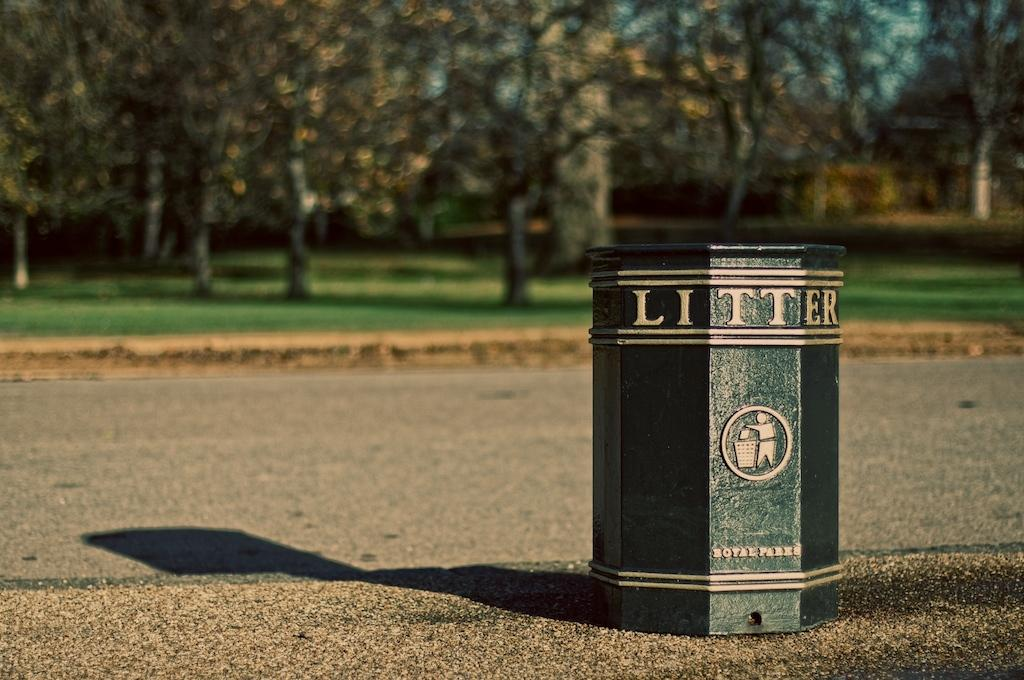<image>
Give a short and clear explanation of the subsequent image. A green trashcan is labeled litter in gold on a tree lined path. 